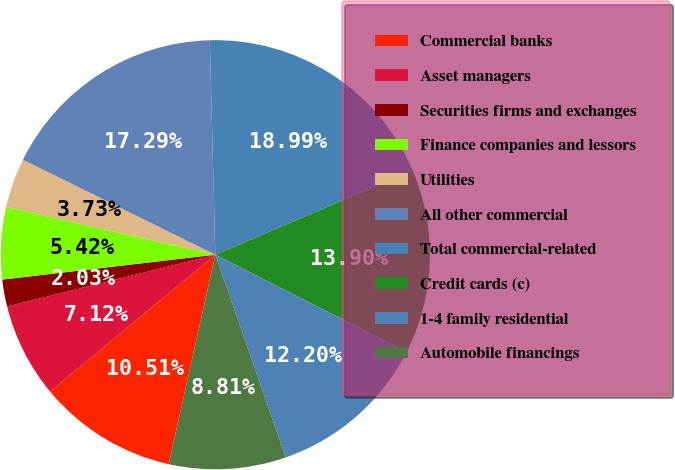Convert chart to OTSL. <chart><loc_0><loc_0><loc_500><loc_500><pie_chart><fcel>Commercial banks<fcel>Asset managers<fcel>Securities firms and exchanges<fcel>Finance companies and lessors<fcel>Utilities<fcel>All other commercial<fcel>Total commercial-related<fcel>Credit cards (c)<fcel>1-4 family residential<fcel>Automobile financings<nl><fcel>10.51%<fcel>7.12%<fcel>2.03%<fcel>5.42%<fcel>3.73%<fcel>17.29%<fcel>18.99%<fcel>13.9%<fcel>12.2%<fcel>8.81%<nl></chart> 